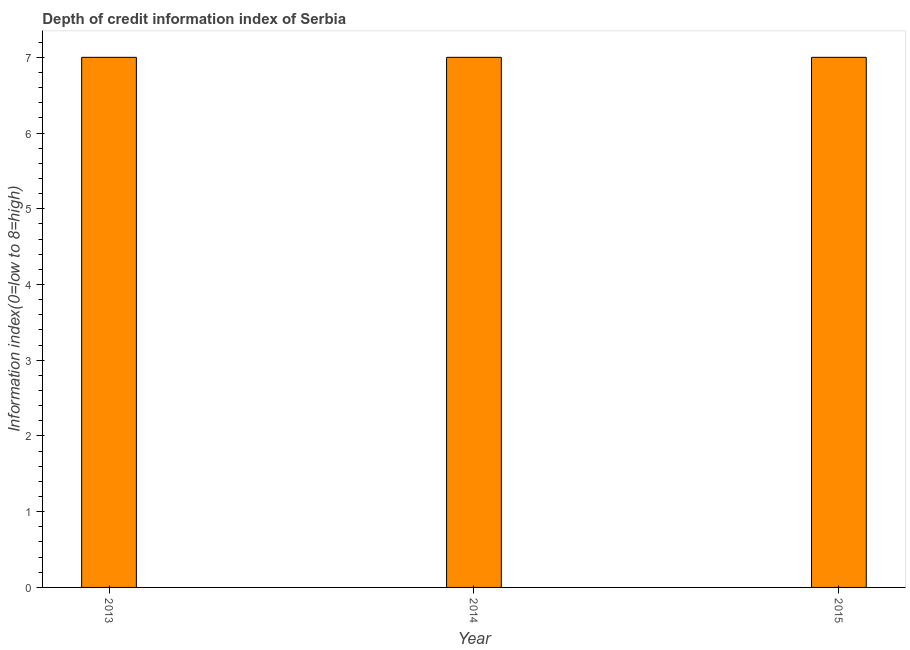Does the graph contain any zero values?
Give a very brief answer. No. Does the graph contain grids?
Your answer should be compact. No. What is the title of the graph?
Make the answer very short. Depth of credit information index of Serbia. What is the label or title of the X-axis?
Give a very brief answer. Year. What is the label or title of the Y-axis?
Your response must be concise. Information index(0=low to 8=high). Across all years, what is the minimum depth of credit information index?
Give a very brief answer. 7. In which year was the depth of credit information index maximum?
Your answer should be compact. 2013. In which year was the depth of credit information index minimum?
Keep it short and to the point. 2013. What is the sum of the depth of credit information index?
Keep it short and to the point. 21. What is the difference between the depth of credit information index in 2013 and 2015?
Ensure brevity in your answer.  0. What is the median depth of credit information index?
Offer a very short reply. 7. What is the difference between the highest and the second highest depth of credit information index?
Offer a terse response. 0. What is the difference between the highest and the lowest depth of credit information index?
Offer a terse response. 0. How many years are there in the graph?
Ensure brevity in your answer.  3. What is the difference between two consecutive major ticks on the Y-axis?
Offer a terse response. 1. What is the Information index(0=low to 8=high) of 2014?
Make the answer very short. 7. What is the Information index(0=low to 8=high) of 2015?
Your response must be concise. 7. What is the difference between the Information index(0=low to 8=high) in 2013 and 2014?
Offer a terse response. 0. What is the difference between the Information index(0=low to 8=high) in 2014 and 2015?
Offer a terse response. 0. What is the ratio of the Information index(0=low to 8=high) in 2013 to that in 2015?
Offer a very short reply. 1. What is the ratio of the Information index(0=low to 8=high) in 2014 to that in 2015?
Provide a short and direct response. 1. 